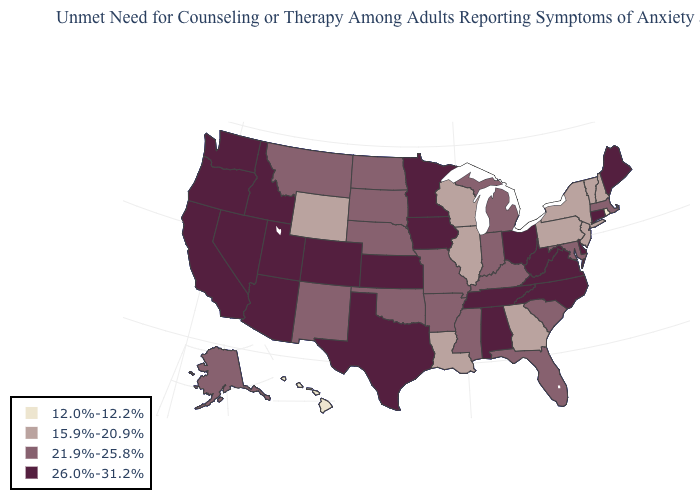What is the value of Connecticut?
Keep it brief. 26.0%-31.2%. What is the value of Utah?
Give a very brief answer. 26.0%-31.2%. What is the value of Kentucky?
Keep it brief. 21.9%-25.8%. Name the states that have a value in the range 12.0%-12.2%?
Be succinct. Hawaii, Rhode Island. Among the states that border Tennessee , does Alabama have the lowest value?
Give a very brief answer. No. Name the states that have a value in the range 12.0%-12.2%?
Be succinct. Hawaii, Rhode Island. What is the highest value in the South ?
Be succinct. 26.0%-31.2%. Which states have the lowest value in the South?
Quick response, please. Georgia, Louisiana. Name the states that have a value in the range 26.0%-31.2%?
Be succinct. Alabama, Arizona, California, Colorado, Connecticut, Delaware, Idaho, Iowa, Kansas, Maine, Minnesota, Nevada, North Carolina, Ohio, Oregon, Tennessee, Texas, Utah, Virginia, Washington, West Virginia. What is the value of Kentucky?
Write a very short answer. 21.9%-25.8%. Which states hav the highest value in the Northeast?
Answer briefly. Connecticut, Maine. What is the value of Mississippi?
Quick response, please. 21.9%-25.8%. Does the map have missing data?
Give a very brief answer. No. Among the states that border Arkansas , which have the highest value?
Short answer required. Tennessee, Texas. Name the states that have a value in the range 12.0%-12.2%?
Write a very short answer. Hawaii, Rhode Island. 